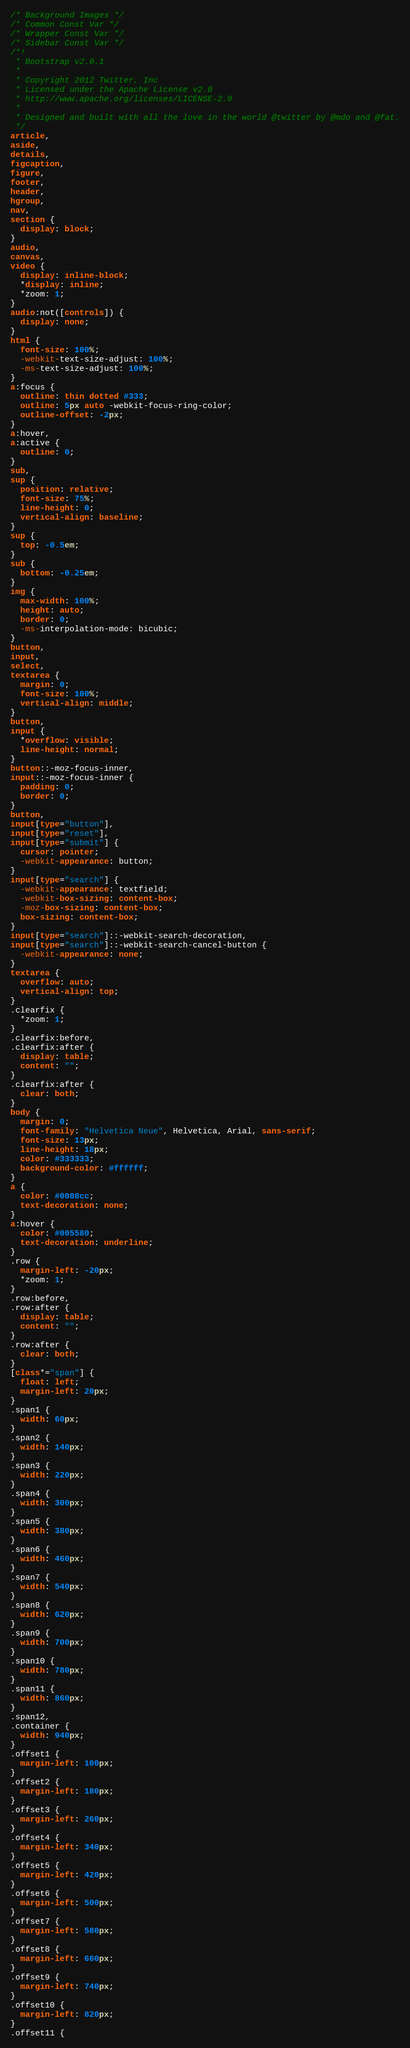Convert code to text. <code><loc_0><loc_0><loc_500><loc_500><_CSS_>/* Background Images */
/* Common Const Var */
/* Wrapper Const Var */
/* Sidebar Const Var */
/*!
 * Bootstrap v2.0.1
 *
 * Copyright 2012 Twitter, Inc
 * Licensed under the Apache License v2.0
 * http://www.apache.org/licenses/LICENSE-2.0
 *
 * Designed and built with all the love in the world @twitter by @mdo and @fat.
 */
article,
aside,
details,
figcaption,
figure,
footer,
header,
hgroup,
nav,
section {
  display: block;
}
audio,
canvas,
video {
  display: inline-block;
  *display: inline;
  *zoom: 1;
}
audio:not([controls]) {
  display: none;
}
html {
  font-size: 100%;
  -webkit-text-size-adjust: 100%;
  -ms-text-size-adjust: 100%;
}
a:focus {
  outline: thin dotted #333;
  outline: 5px auto -webkit-focus-ring-color;
  outline-offset: -2px;
}
a:hover,
a:active {
  outline: 0;
}
sub,
sup {
  position: relative;
  font-size: 75%;
  line-height: 0;
  vertical-align: baseline;
}
sup {
  top: -0.5em;
}
sub {
  bottom: -0.25em;
}
img {
  max-width: 100%;
  height: auto;
  border: 0;
  -ms-interpolation-mode: bicubic;
}
button,
input,
select,
textarea {
  margin: 0;
  font-size: 100%;
  vertical-align: middle;
}
button,
input {
  *overflow: visible;
  line-height: normal;
}
button::-moz-focus-inner,
input::-moz-focus-inner {
  padding: 0;
  border: 0;
}
button,
input[type="button"],
input[type="reset"],
input[type="submit"] {
  cursor: pointer;
  -webkit-appearance: button;
}
input[type="search"] {
  -webkit-appearance: textfield;
  -webkit-box-sizing: content-box;
  -moz-box-sizing: content-box;
  box-sizing: content-box;
}
input[type="search"]::-webkit-search-decoration,
input[type="search"]::-webkit-search-cancel-button {
  -webkit-appearance: none;
}
textarea {
  overflow: auto;
  vertical-align: top;
}
.clearfix {
  *zoom: 1;
}
.clearfix:before,
.clearfix:after {
  display: table;
  content: "";
}
.clearfix:after {
  clear: both;
}
body {
  margin: 0;
  font-family: "Helvetica Neue", Helvetica, Arial, sans-serif;
  font-size: 13px;
  line-height: 18px;
  color: #333333;
  background-color: #ffffff;
}
a {
  color: #0088cc;
  text-decoration: none;
}
a:hover {
  color: #005580;
  text-decoration: underline;
}
.row {
  margin-left: -20px;
  *zoom: 1;
}
.row:before,
.row:after {
  display: table;
  content: "";
}
.row:after {
  clear: both;
}
[class*="span"] {
  float: left;
  margin-left: 20px;
}
.span1 {
  width: 60px;
}
.span2 {
  width: 140px;
}
.span3 {
  width: 220px;
}
.span4 {
  width: 300px;
}
.span5 {
  width: 380px;
}
.span6 {
  width: 460px;
}
.span7 {
  width: 540px;
}
.span8 {
  width: 620px;
}
.span9 {
  width: 700px;
}
.span10 {
  width: 780px;
}
.span11 {
  width: 860px;
}
.span12,
.container {
  width: 940px;
}
.offset1 {
  margin-left: 100px;
}
.offset2 {
  margin-left: 180px;
}
.offset3 {
  margin-left: 260px;
}
.offset4 {
  margin-left: 340px;
}
.offset5 {
  margin-left: 420px;
}
.offset6 {
  margin-left: 500px;
}
.offset7 {
  margin-left: 580px;
}
.offset8 {
  margin-left: 660px;
}
.offset9 {
  margin-left: 740px;
}
.offset10 {
  margin-left: 820px;
}
.offset11 {</code> 